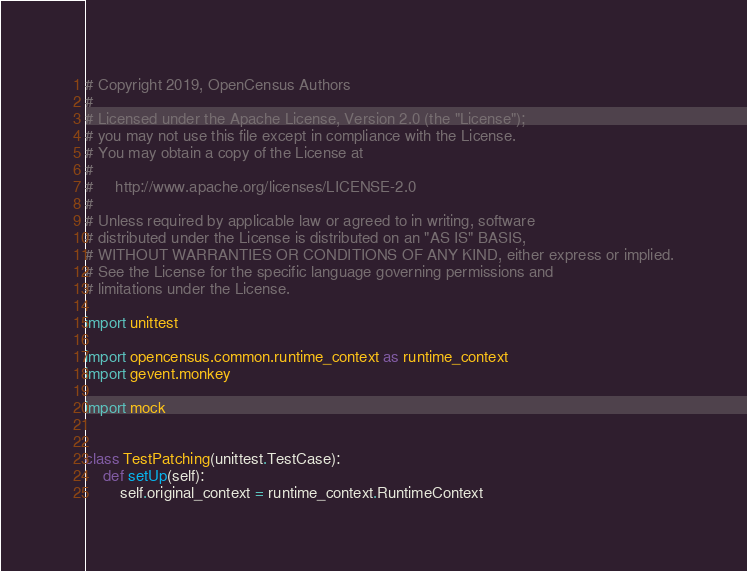Convert code to text. <code><loc_0><loc_0><loc_500><loc_500><_Python_># Copyright 2019, OpenCensus Authors
#
# Licensed under the Apache License, Version 2.0 (the "License");
# you may not use this file except in compliance with the License.
# You may obtain a copy of the License at
#
#     http://www.apache.org/licenses/LICENSE-2.0
#
# Unless required by applicable law or agreed to in writing, software
# distributed under the License is distributed on an "AS IS" BASIS,
# WITHOUT WARRANTIES OR CONDITIONS OF ANY KIND, either express or implied.
# See the License for the specific language governing permissions and
# limitations under the License.

import unittest

import opencensus.common.runtime_context as runtime_context
import gevent.monkey

import mock


class TestPatching(unittest.TestCase):
    def setUp(self):
        self.original_context = runtime_context.RuntimeContext
</code> 